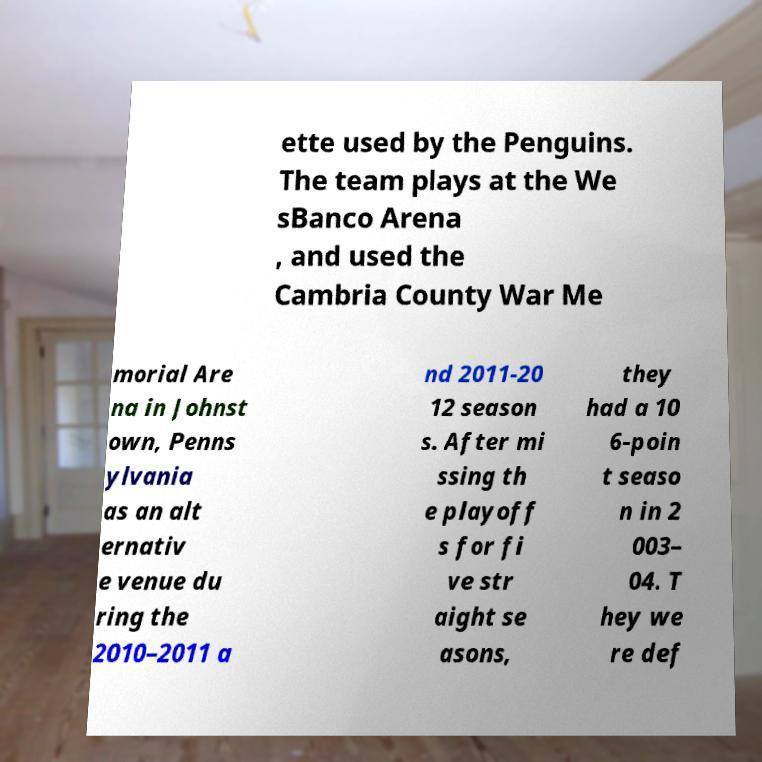I need the written content from this picture converted into text. Can you do that? ette used by the Penguins. The team plays at the We sBanco Arena , and used the Cambria County War Me morial Are na in Johnst own, Penns ylvania as an alt ernativ e venue du ring the 2010–2011 a nd 2011-20 12 season s. After mi ssing th e playoff s for fi ve str aight se asons, they had a 10 6-poin t seaso n in 2 003– 04. T hey we re def 